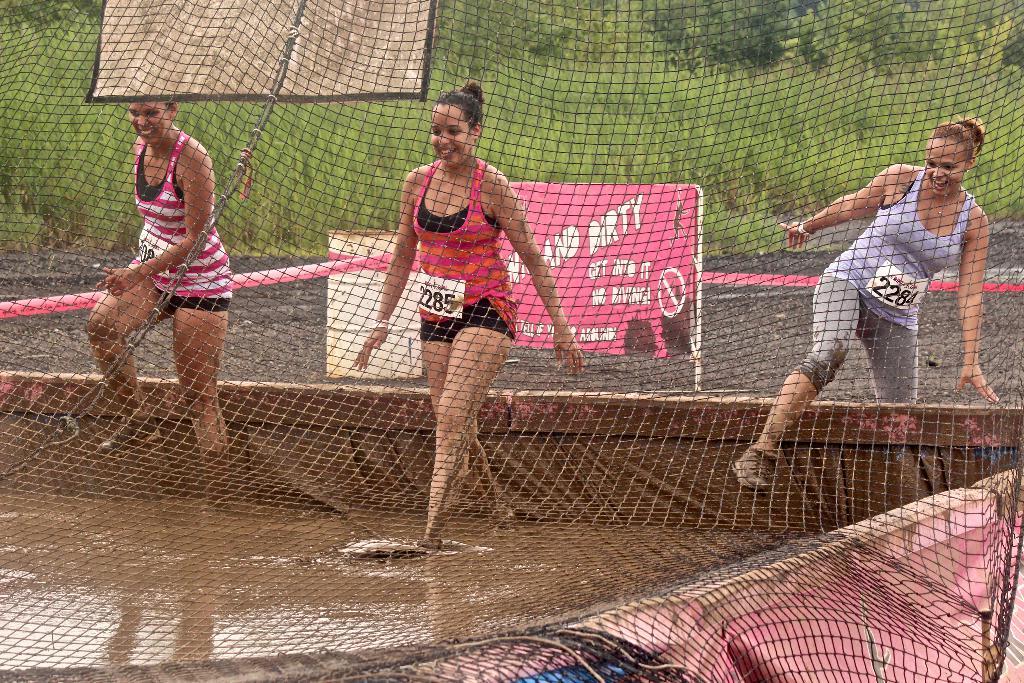What is the number of the racer in the purple tank top?
Provide a succinct answer. 2284. 